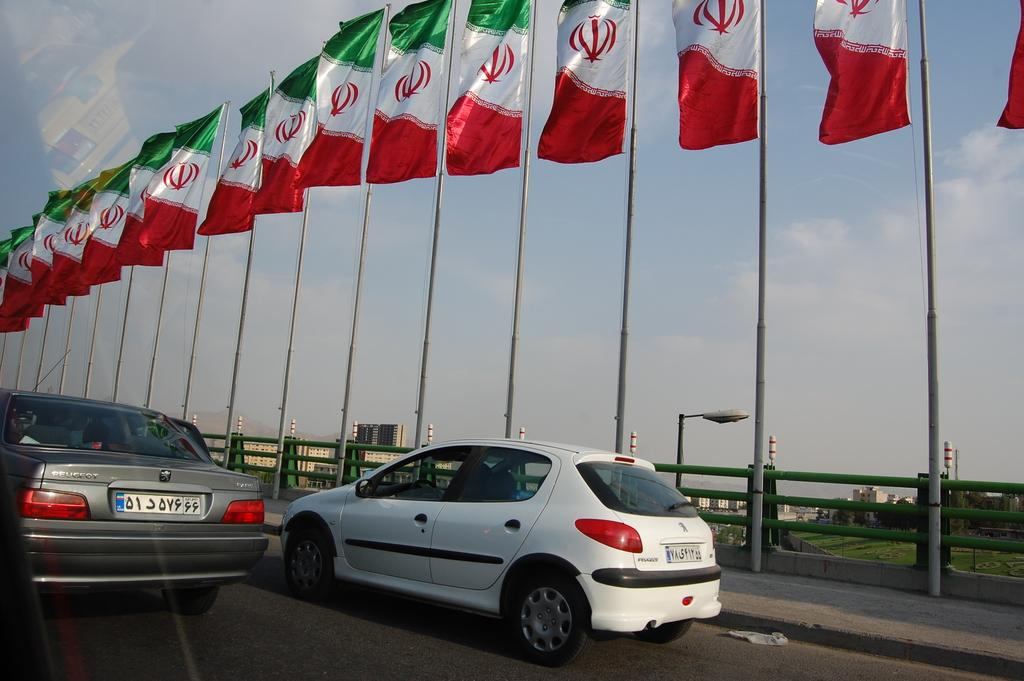What can be seen on the road in the image? There are vehicles on the road in the image. What is located on the sidewalks in the image? There are flags on the sidewalks in the image. Can you hear the thunder in the image? There is no mention of thunder or any sound in the image, so it cannot be heard. 